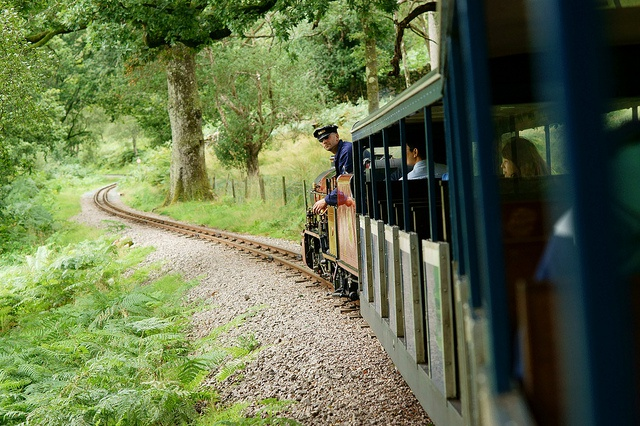Describe the objects in this image and their specific colors. I can see train in olive, black, gray, darkgray, and darkgreen tones, people in olive, black, navy, blue, and gray tones, people in olive and black tones, and people in olive, black, purple, gray, and maroon tones in this image. 